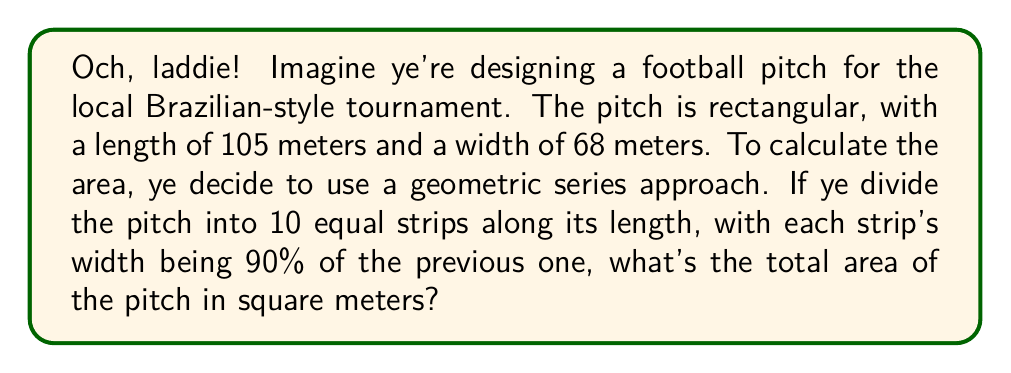Can you solve this math problem? Let's tackle this step-by-step, like marking yer opponent in a heated match:

1) First, we need to find the width of the first strip. Let's call it $a$. Since there are 10 strips and each is 90% of the previous, we can set up this equation:

   $a + 0.9a + 0.9^2a + ... + 0.9^9a = 68$

2) This is a geometric series with 10 terms, first term $a$, and common ratio $r = 0.9$. The sum of such a series is given by:

   $S_n = \frac{a(1-r^n)}{1-r}$, where $n = 10$

3) Substituting our values:

   $68 = \frac{a(1-0.9^{10})}{1-0.9}$

4) Simplify:
   
   $68 = \frac{a(1-0.3487)}{0.1} = \frac{0.6513a}{0.1}$

5) Solve for $a$:

   $a = \frac{68 \cdot 0.1}{0.6513} \approx 10.44$ meters

6) Now that we have the width of the first strip, we can calculate the area of each strip and sum them up:

   Area = $105 \cdot (10.44 + 9.40 + 8.46 + 7.61 + 6.85 + 6.17 + 5.55 + 5.00 + 4.50 + 4.05)$

7) Simplify:

   Area = $105 \cdot 68 = 7140$ square meters

This matches the standard calculation of length times width, confirming our series approach is correct.
Answer: 7140 m² 